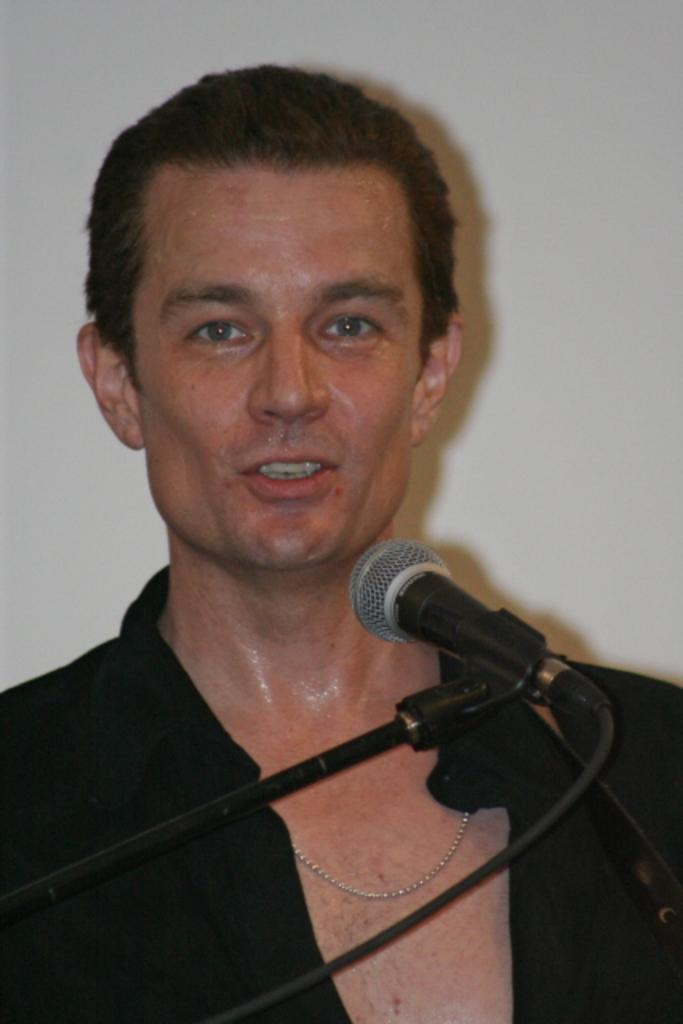What object with a stand is visible in the image? There is a microphone with a stand in the image. Can you describe the person in the image? There is a person in the image, but their appearance or actions are not specified. What can be seen in the background of the image? There is a wall in the background of the image. How many matches are being used by the person in the image? There is no mention of matches or any activity involving matches in the image. 